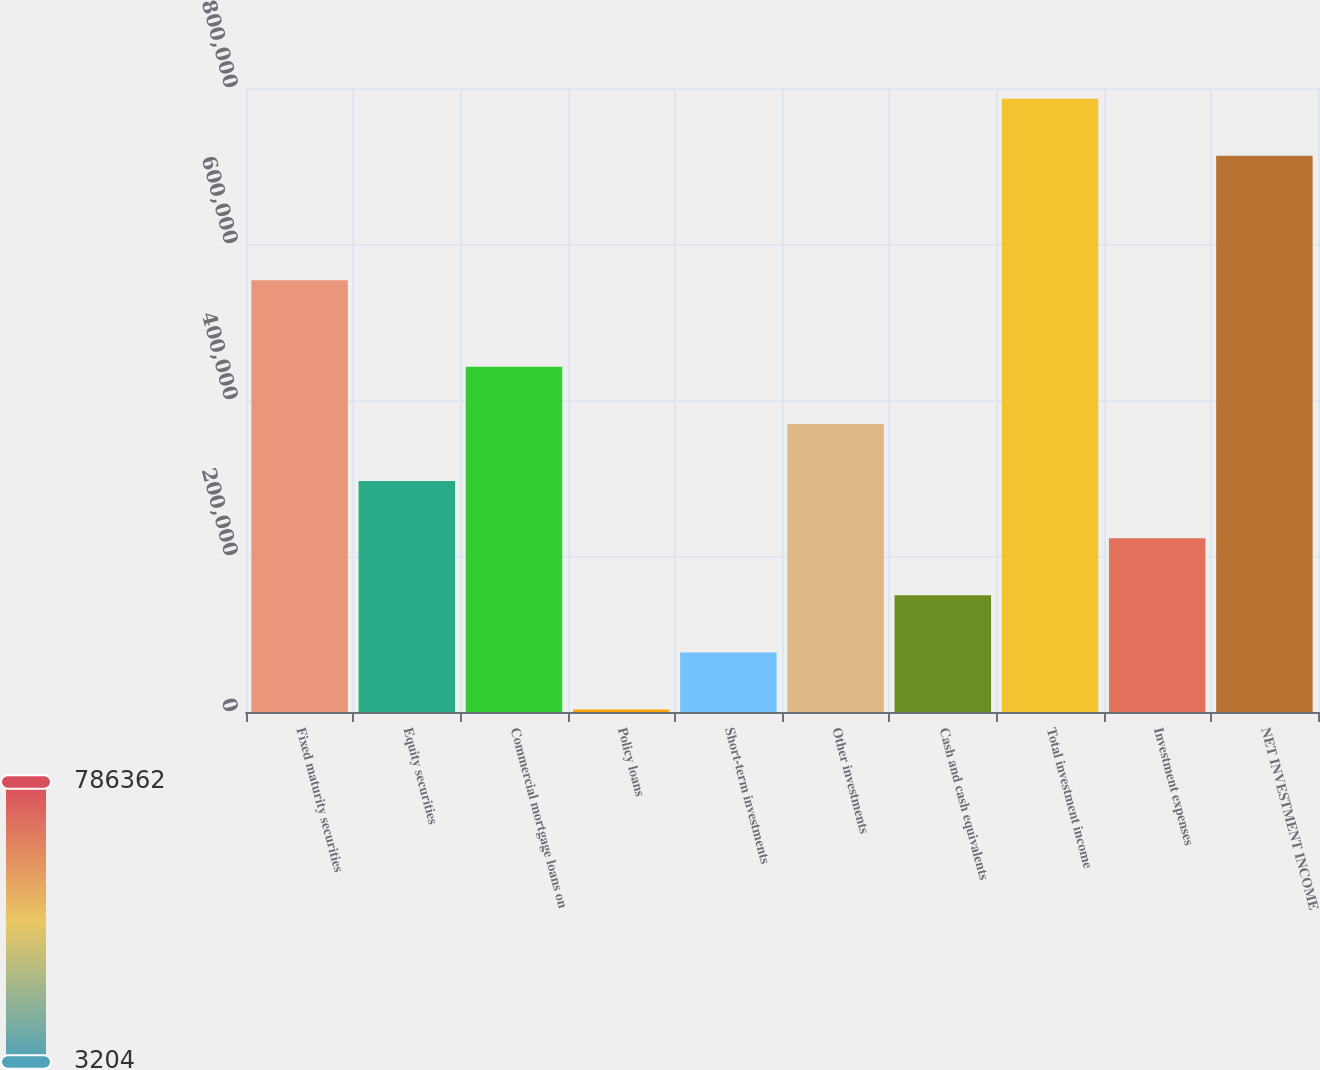Convert chart. <chart><loc_0><loc_0><loc_500><loc_500><bar_chart><fcel>Fixed maturity securities<fcel>Equity securities<fcel>Commercial mortgage loans on<fcel>Policy loans<fcel>Short-term investments<fcel>Other investments<fcel>Cash and cash equivalents<fcel>Total investment income<fcel>Investment expenses<fcel>NET INVESTMENT INCOME<nl><fcel>553668<fcel>296140<fcel>442608<fcel>3204<fcel>76438<fcel>369374<fcel>149672<fcel>786362<fcel>222906<fcel>713128<nl></chart> 